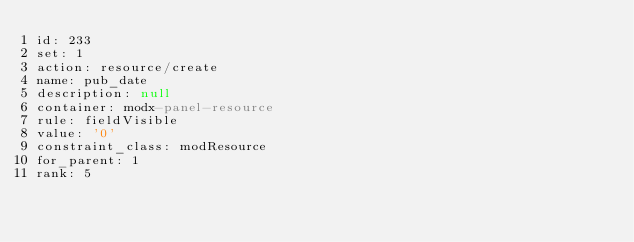<code> <loc_0><loc_0><loc_500><loc_500><_YAML_>id: 233
set: 1
action: resource/create
name: pub_date
description: null
container: modx-panel-resource
rule: fieldVisible
value: '0'
constraint_class: modResource
for_parent: 1
rank: 5
</code> 